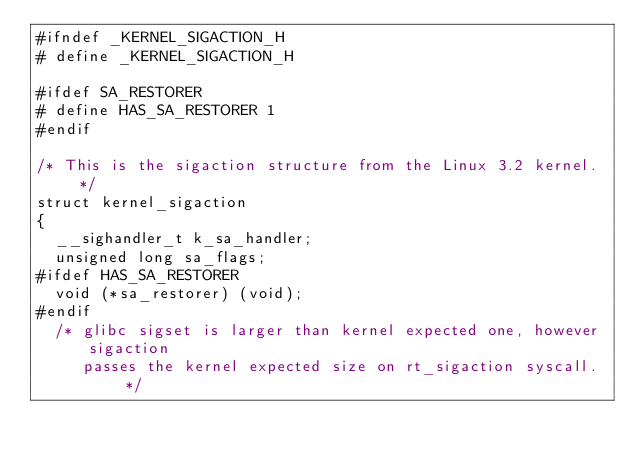<code> <loc_0><loc_0><loc_500><loc_500><_C_>#ifndef _KERNEL_SIGACTION_H
# define _KERNEL_SIGACTION_H

#ifdef SA_RESTORER
# define HAS_SA_RESTORER 1
#endif

/* This is the sigaction structure from the Linux 3.2 kernel.  */
struct kernel_sigaction
{
  __sighandler_t k_sa_handler;
  unsigned long sa_flags;
#ifdef HAS_SA_RESTORER
  void (*sa_restorer) (void);
#endif
  /* glibc sigset is larger than kernel expected one, however sigaction
     passes the kernel expected size on rt_sigaction syscall.  */</code> 